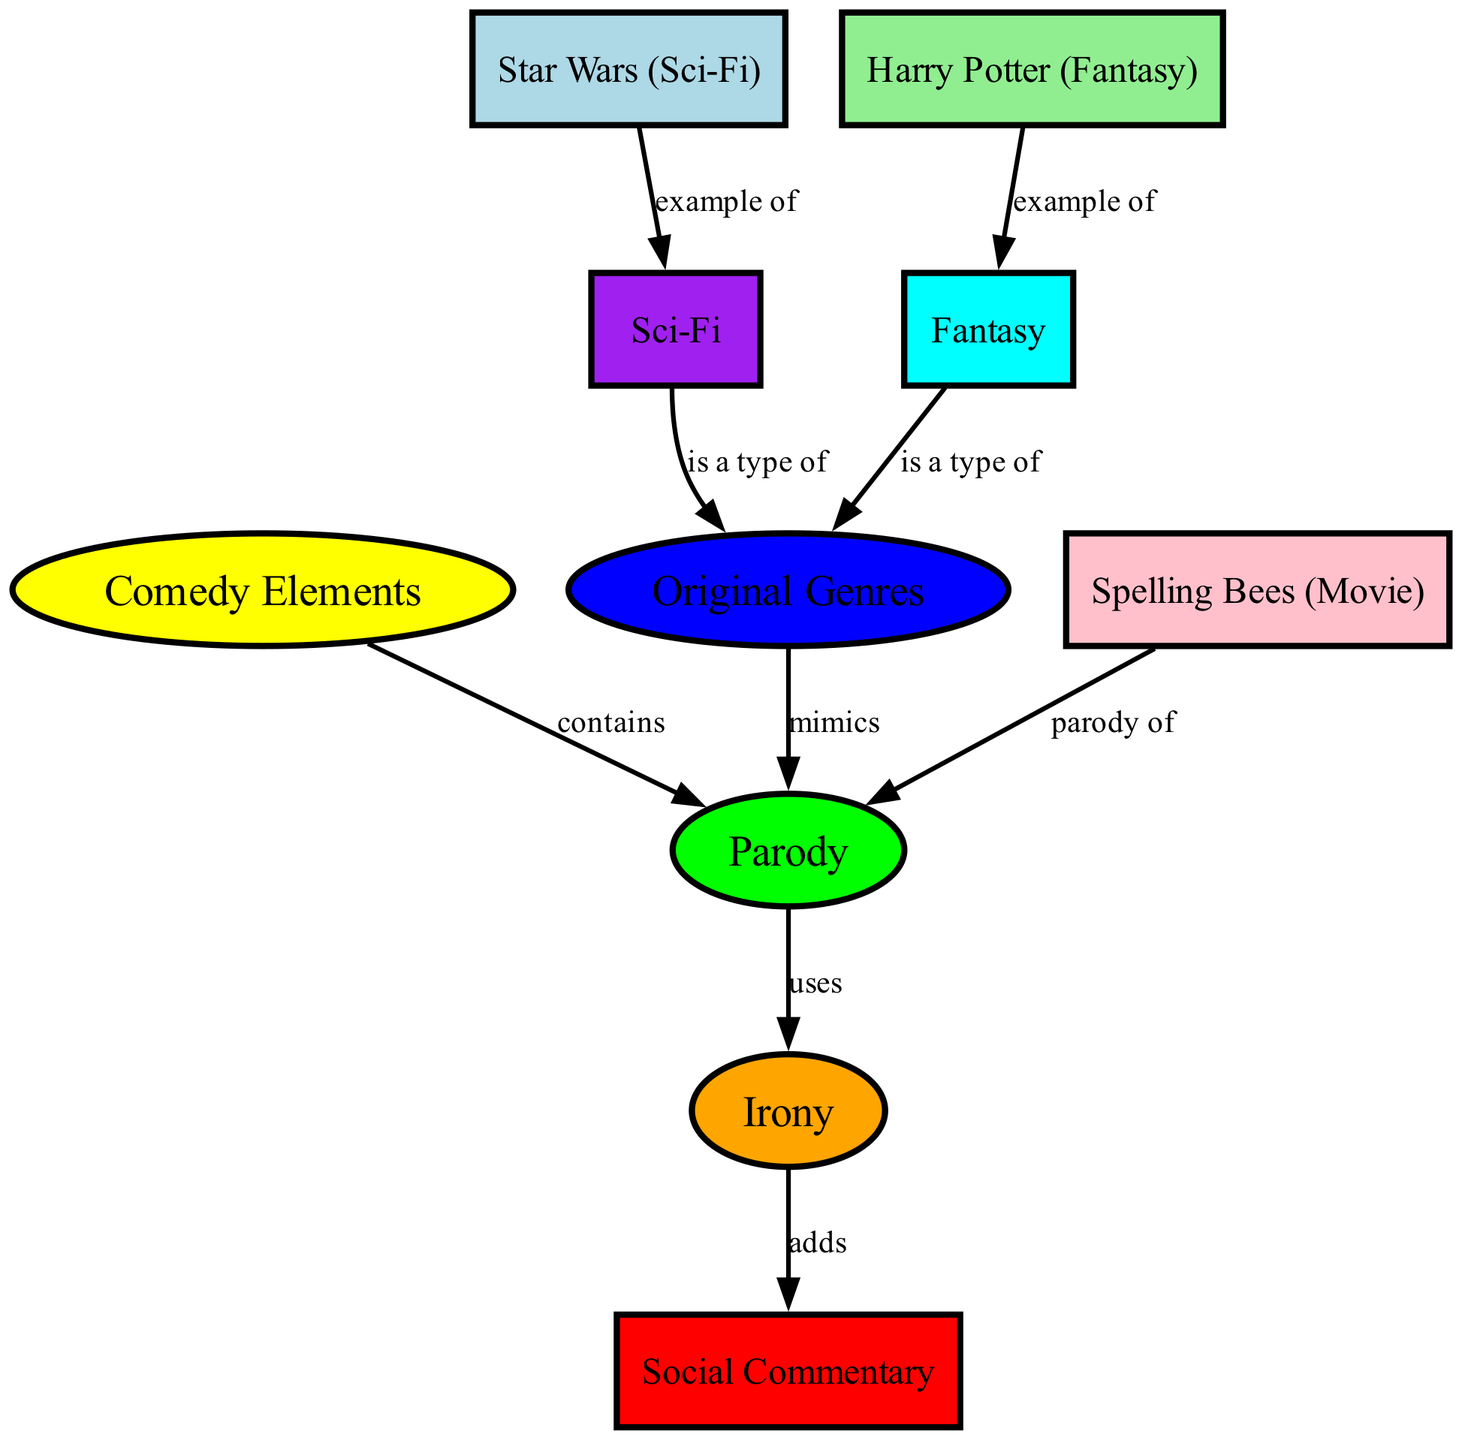What is the color of the node representing "Comedy Elements"? The node labeled "Comedy Elements" is shown in the diagram, and its corresponding color is indicated as yellow.
Answer: yellow How many nodes are in the diagram? By counting the nodes listed in the provided data, there are a total of 10 nodes present in the diagram.
Answer: 10 Which genre is a parody of "Spelling Bees"? The edge labeled "parody of" connects "Spelling Bees" to the node "Parody," indicating that "Spelling Bees" is directly parodied, making it the answer.
Answer: Parody What type of relationship exists between "Original Genres" and "Parody"? The edge labeled "mimics" connects "Original Genres" to "Parody," indicating that parody mimics original genres, which defines the relationship.
Answer: mimics Which two genres are examples of original genres in the diagram? The nodes "Sci-Fi" and "Fantasy" are labeled as types of "Original Genres," and both represent distinct examples of original genres in the diagram.
Answer: Sci-Fi, Fantasy What element is added to parody through irony? The edge labeled "adds" connects "Irony" to "Social Commentary," suggesting that irony incorporates social commentary as an element when blended with parody.
Answer: Social Commentary How does "Star Wars" relate to "Sci-Fi"? The edge labeled "example of" indicates that "Star Wars" represents a clear example of the "Sci-Fi" genre in the diagram, establishing this direct relationship.
Answer: example of What type of edge connects "Comedy Elements" to "Parody"? The relationship between "Comedy Elements" and "Parody" is conveyed through the edge labeled "contains," suggesting that comedy elements are contained within parody.
Answer: contains How many edges lead to the "Parody" node? By examining the diagram, there are four connections (edges) leading to the "Parody" node, representing different relationships with other genres and elements.
Answer: 4 